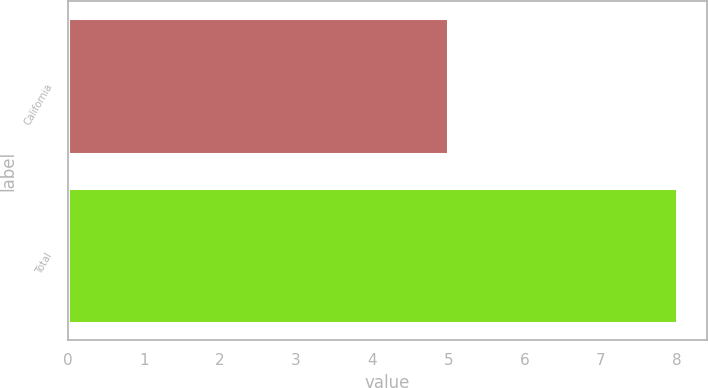<chart> <loc_0><loc_0><loc_500><loc_500><bar_chart><fcel>California<fcel>Total<nl><fcel>5<fcel>8<nl></chart> 